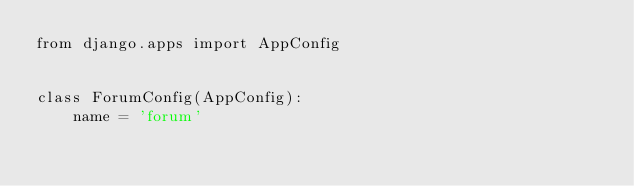Convert code to text. <code><loc_0><loc_0><loc_500><loc_500><_Python_>from django.apps import AppConfig


class ForumConfig(AppConfig):
    name = 'forum'
</code> 